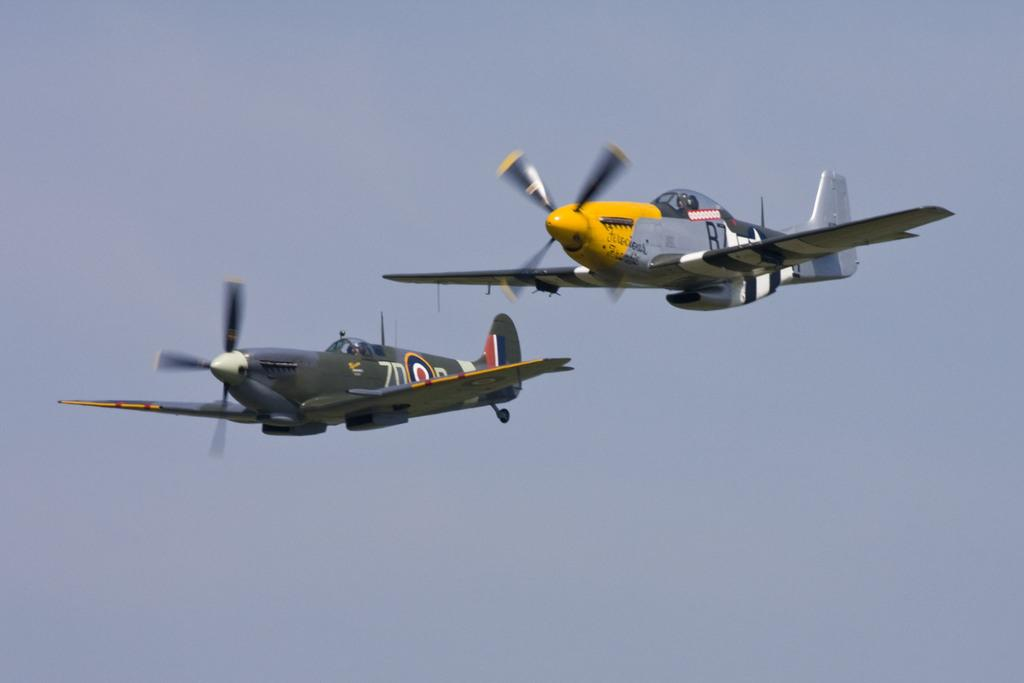<image>
Write a terse but informative summary of the picture. Two planes, one marked R7, fly side by side. 